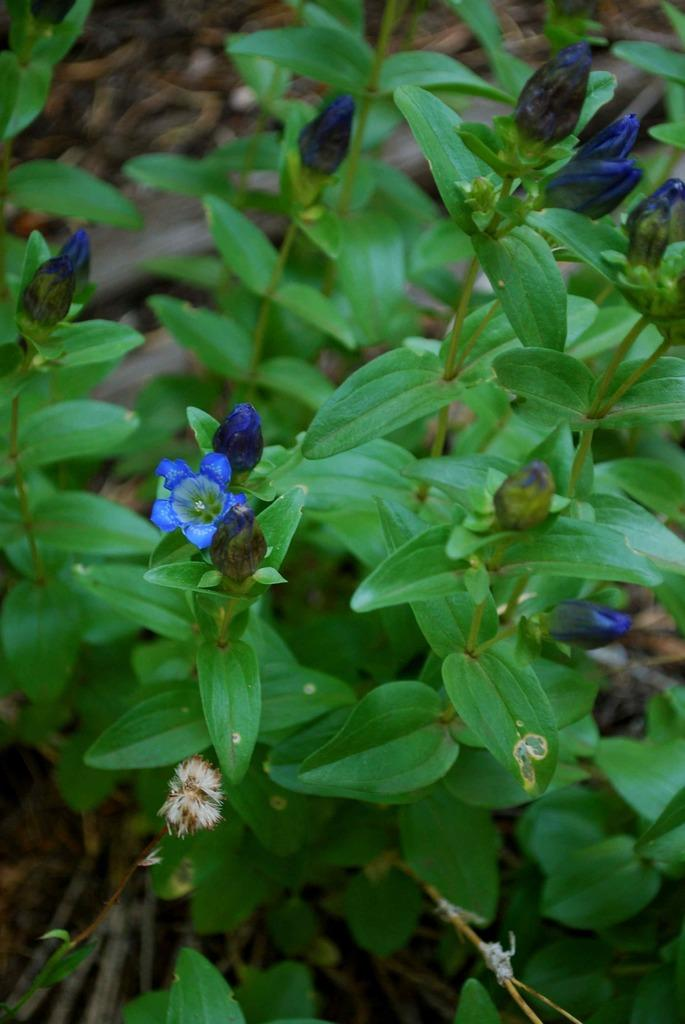What type of plant is visible in the image? There is a flower plant in the image. What nation is represented by the rat in the image? There is no rat present in the image, and therefore no nation can be represented by it. 